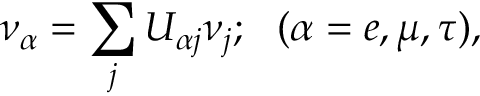<formula> <loc_0><loc_0><loc_500><loc_500>\nu _ { \alpha } = \sum _ { j } U _ { \alpha j } \nu _ { j } ; \, ( \alpha = e , \mu , \tau ) ,</formula> 